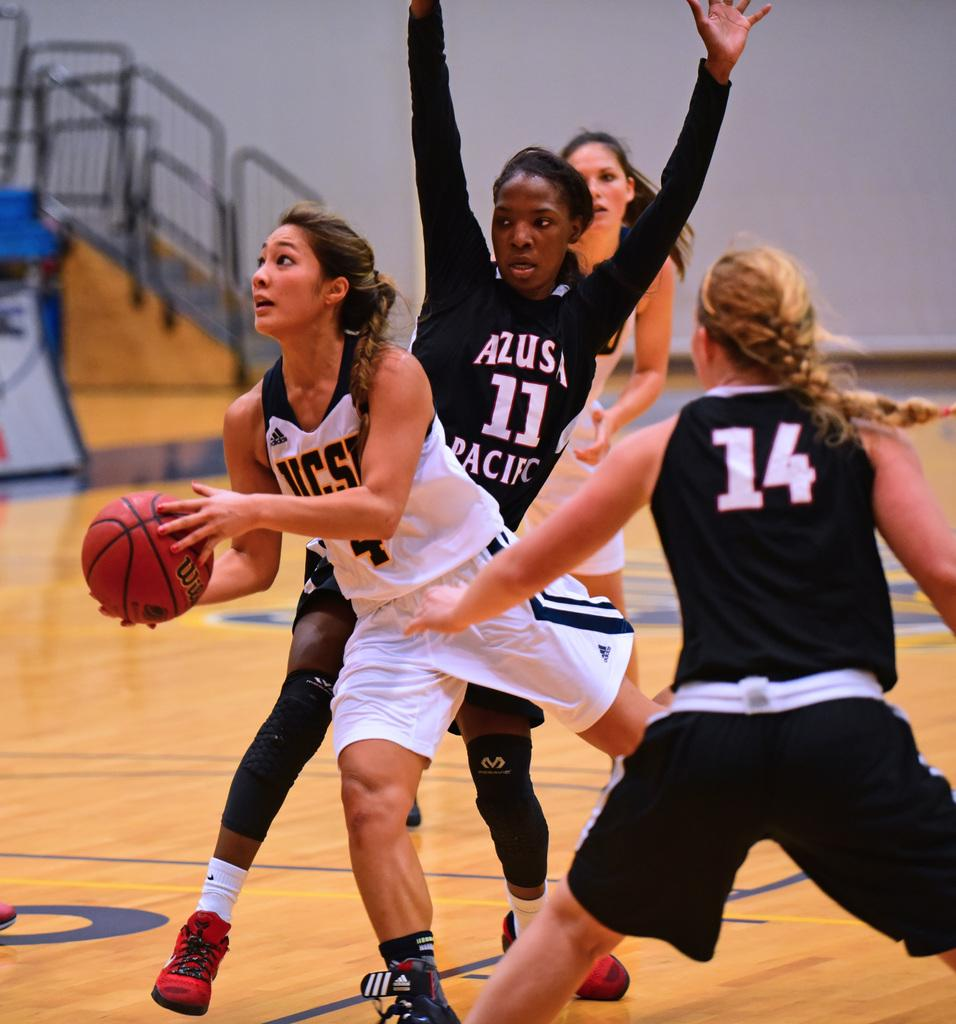<image>
Describe the image concisely. The girl in the black jersey is number 11 